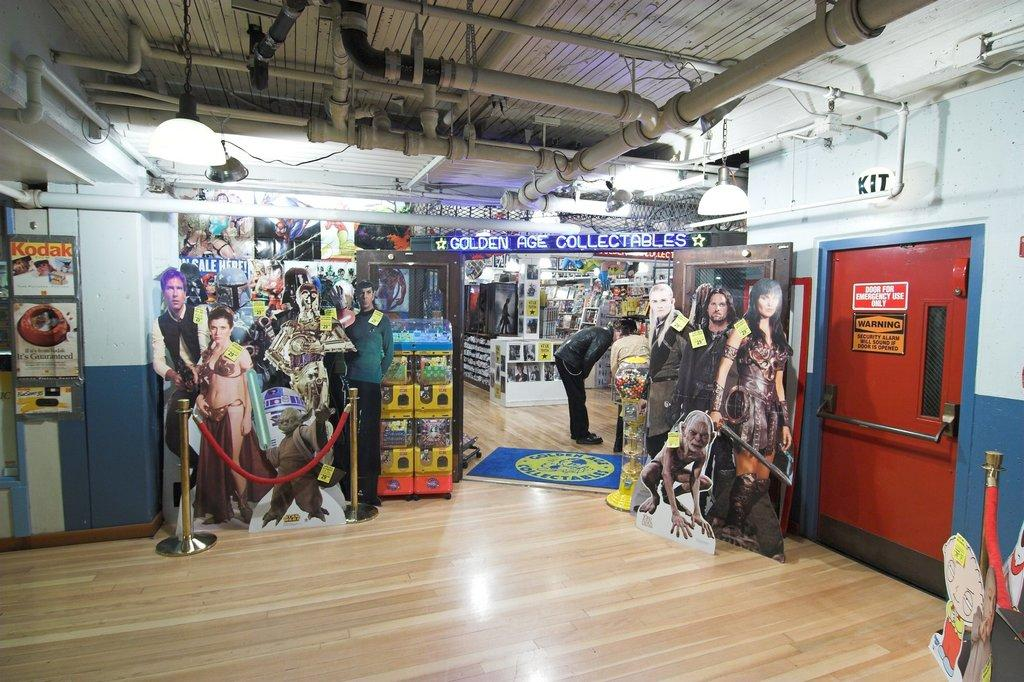What color is the door that is visible in the image? There is a red door in the image. What is the main structure in the image? There is a wall in the image. What type of plumbing feature can be seen in the image? There are pipes in the image. What type of illumination is present in the image? There are lights in the image. What is the position of the person in the image? There is a person on the floor in the image. What other objects are present on the floor in the image? There are other objects on the floor in the image. How does the comparison between the stone and the door in the image affect the overall aesthetic? There is no stone present in the image, so it is not possible to make a comparison between the stone and the door. 